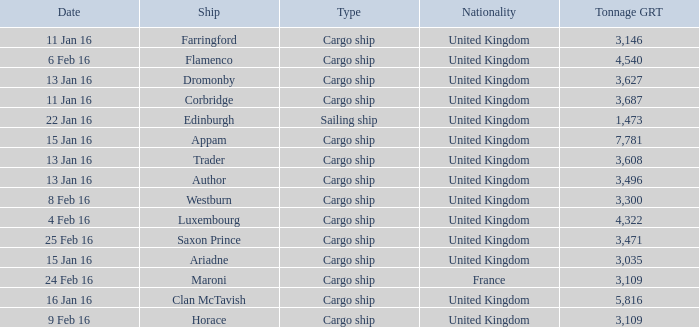What is the tonnage grt of the ship author? 3496.0. 